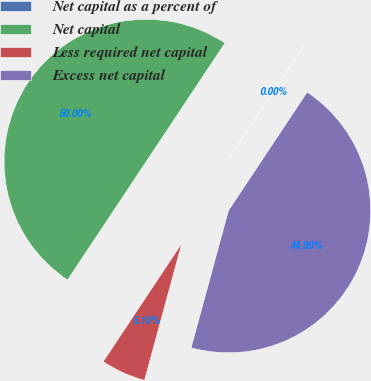Convert chart. <chart><loc_0><loc_0><loc_500><loc_500><pie_chart><fcel>Net capital as a percent of<fcel>Net capital<fcel>Less required net capital<fcel>Excess net capital<nl><fcel>0.0%<fcel>50.0%<fcel>5.1%<fcel>44.9%<nl></chart> 